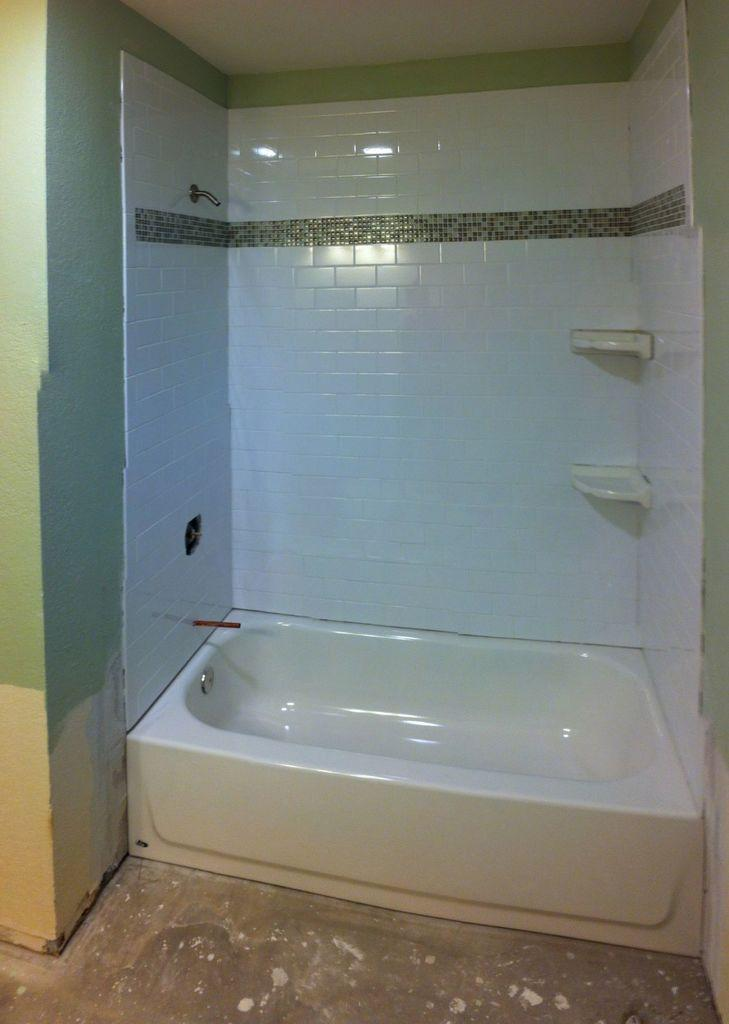What is the main object in the image? There is a bathtub in the image. What is located behind the bathtub? There is a wall in the image. What type of material covers the wall and bathtub? Tiles are present in the image. What is used to hold soap in the image? Soap holders are visible in the image. What else can be seen in the image besides the bathtub and tiles? There are objects in the image. What is the surface beneath the bathtub? The floor is visible in the image. What type of crime is being committed in the image? There is no crime being committed in the image; it features a bathtub and related elements. How does the lift function in the image? There is no lift present in the image. 